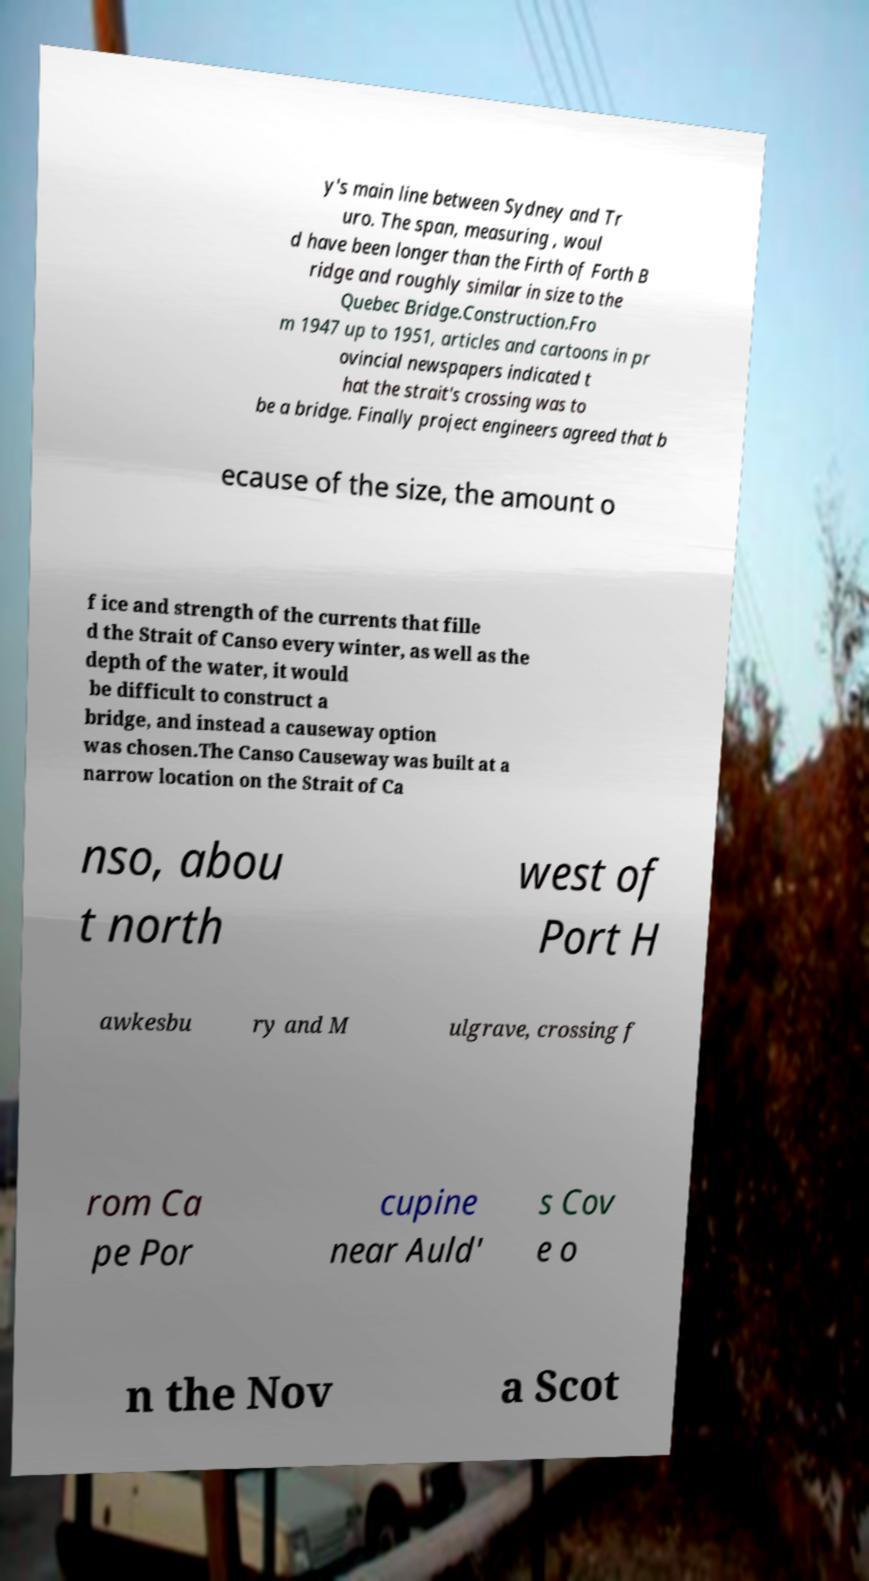For documentation purposes, I need the text within this image transcribed. Could you provide that? y's main line between Sydney and Tr uro. The span, measuring , woul d have been longer than the Firth of Forth B ridge and roughly similar in size to the Quebec Bridge.Construction.Fro m 1947 up to 1951, articles and cartoons in pr ovincial newspapers indicated t hat the strait's crossing was to be a bridge. Finally project engineers agreed that b ecause of the size, the amount o f ice and strength of the currents that fille d the Strait of Canso every winter, as well as the depth of the water, it would be difficult to construct a bridge, and instead a causeway option was chosen.The Canso Causeway was built at a narrow location on the Strait of Ca nso, abou t north west of Port H awkesbu ry and M ulgrave, crossing f rom Ca pe Por cupine near Auld' s Cov e o n the Nov a Scot 